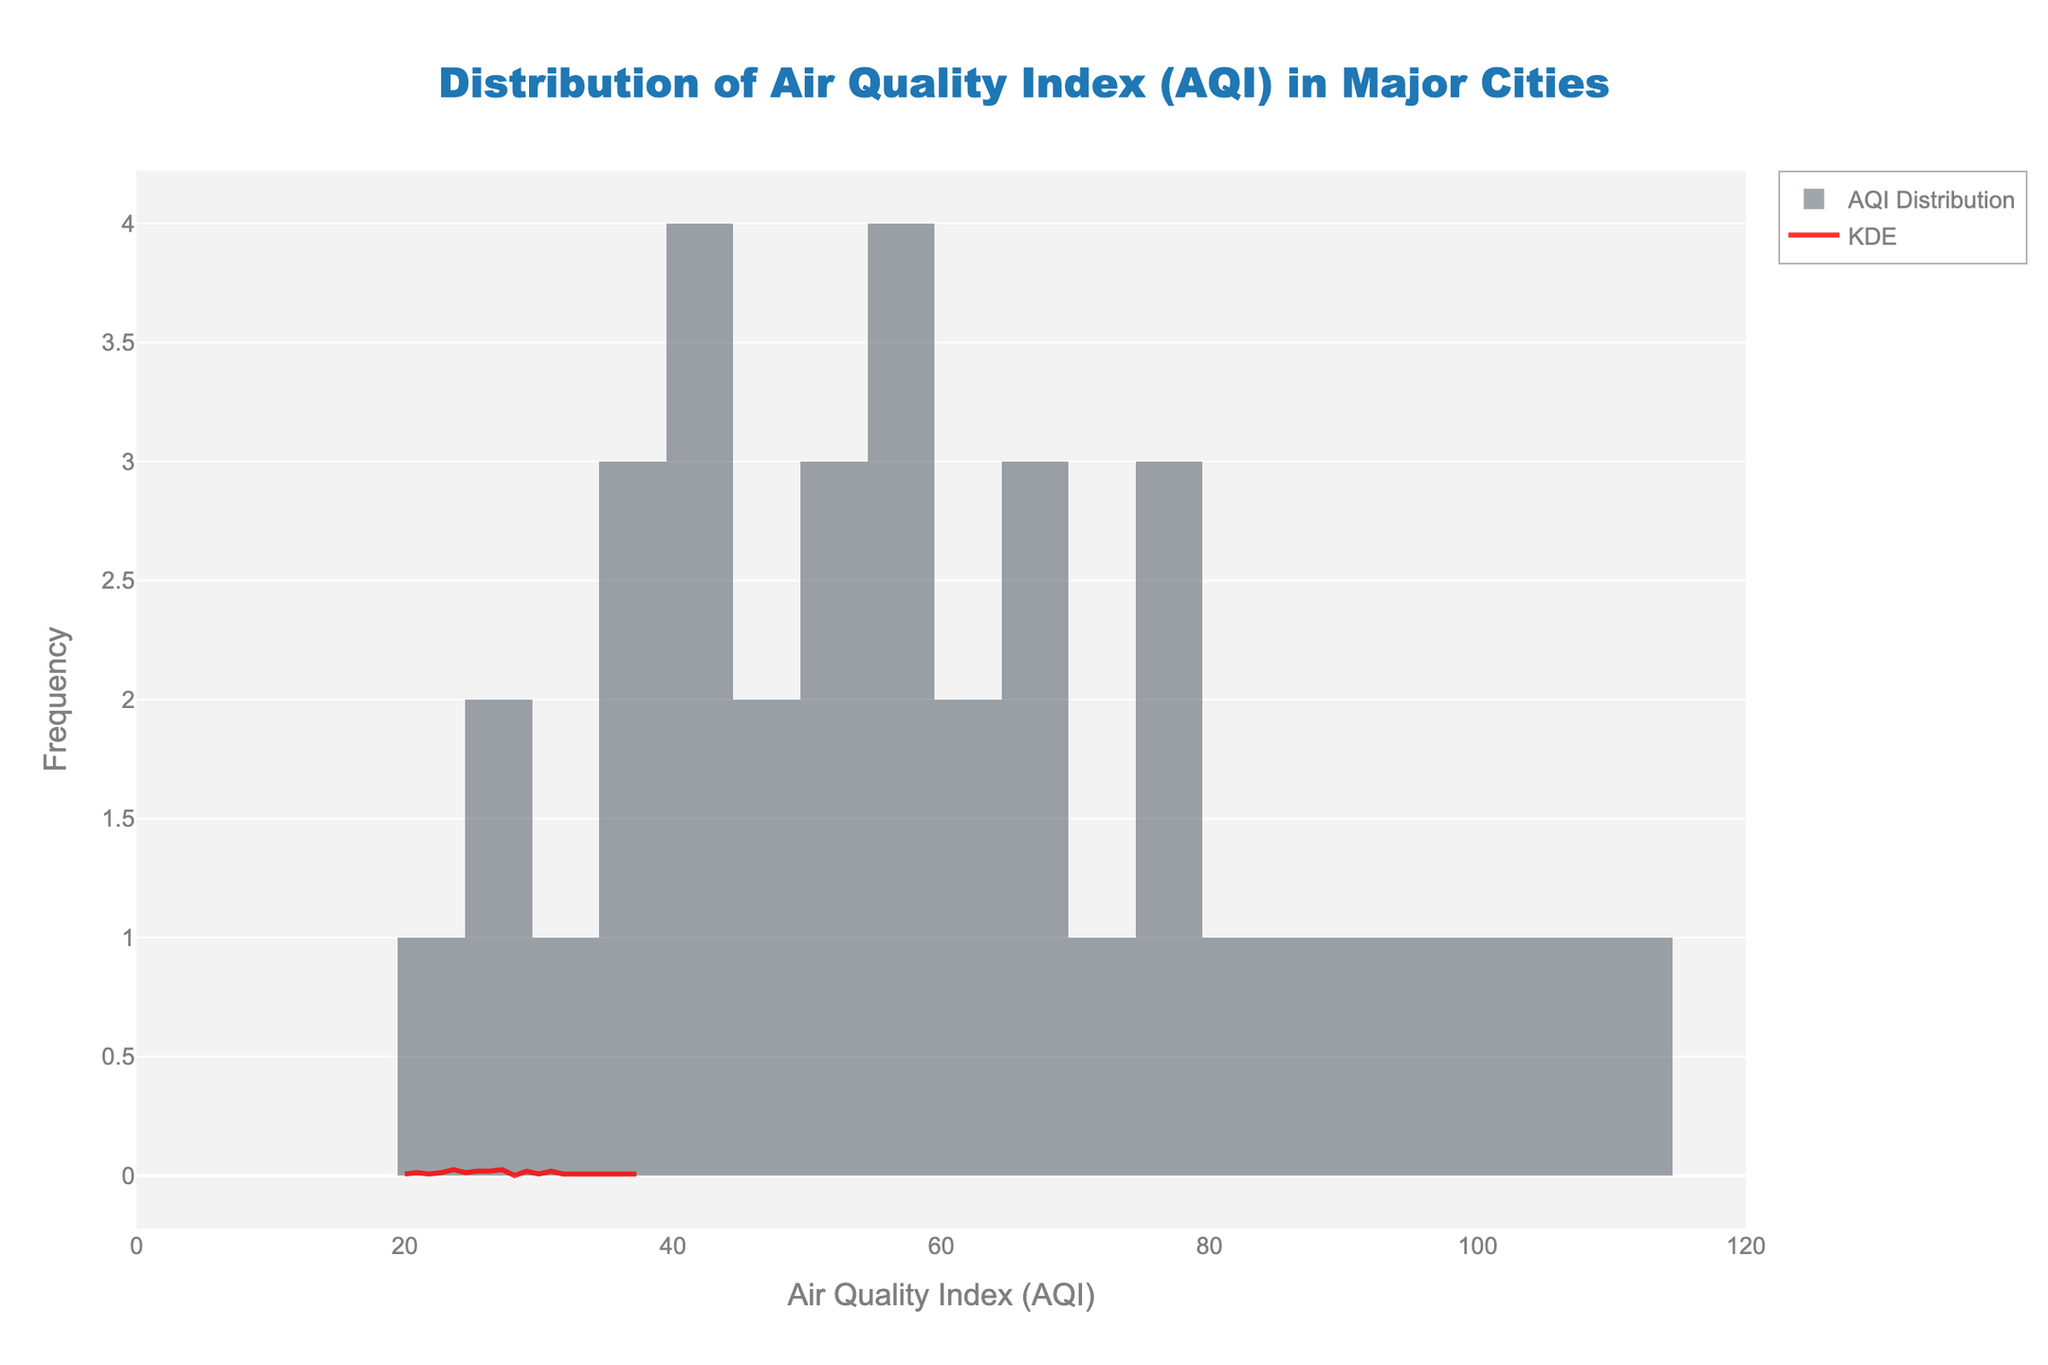What is the title of the figure? The title is at the top center of the figure and clearly states the main focus of the plot.
Answer: Distribution of Air Quality Index (AQI) in Major Cities What do the x-axis and y-axis represent? The x-axis title reads "Air Quality Index (AQI)" indicating the variable measured, while the y-axis title reads "Frequency" indicating how often each AQI value occurs.
Answer: AQI and Frequency How many bins were used in the histogram? Counting the bars or referring to the figure legend, it can be observed that there are 20 bins used for the histogram.
Answer: 20 Which AQI range has the highest frequency? Observing the height of the bars in the histogram, the highest bar falls within the AQI range of approximately 50 to 60.
Answer: 50 to 60 What is the color of the KDE (Kernel Density Estimate) line in the plot? The KDE line is shown in a distinctive color that stands out for clarity—it is red as indicated by the explanation of the plot.
Answer: Red What is the average AQI value for the cities plotted? The average AQI can be estimated by looking at the middle range of the most densely populated bins and confirming it through computation if necessary. The average seems to fall approximately between 50 and 60.
Answer: 50 to 60 Which city has the highest AQI, and what is its value? Referring to the data behind the figure, the city with the highest AQI can be identified. According to the data provided, Delhi has the highest AQI with a value of 110.
Answer: Delhi, 110 Does any city have an AQI lower than 20? Observing the x-axis for any AQI values below 20 and referring to the data provided, Melbourne, with an AQI of 20, refutes this. No city has an AQI lower than 20.
Answer: No How many cities have an AQI greater than 80? By counting the data points and bars exceeding the AQI value of 80 on the x-axis, or referring to the given data, there are five cities: Mexico City (85), Beijing (100), Shanghai (95), Delhi (110), Mumbai (90), Jakarta (82), and Cairo (105).
Answer: 7 Which city has the lowest AQI, and what is its value? Referring to the data behind the figure, the city with the lowest AQI can be identified. According to the provided data, Sydney has the lowest AQI at 25.
Answer: Sydney, 25 